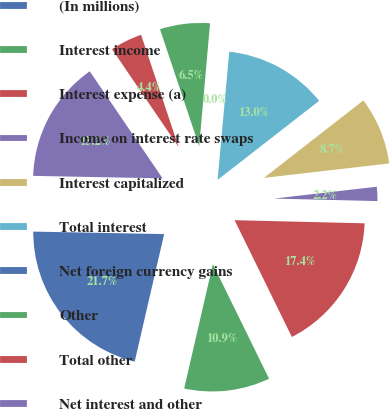<chart> <loc_0><loc_0><loc_500><loc_500><pie_chart><fcel>(In millions)<fcel>Interest income<fcel>Interest expense (a)<fcel>Income on interest rate swaps<fcel>Interest capitalized<fcel>Total interest<fcel>Net foreign currency gains<fcel>Other<fcel>Total other<fcel>Net interest and other<nl><fcel>21.69%<fcel>10.87%<fcel>17.36%<fcel>2.21%<fcel>8.7%<fcel>13.03%<fcel>0.04%<fcel>6.54%<fcel>4.37%<fcel>15.19%<nl></chart> 